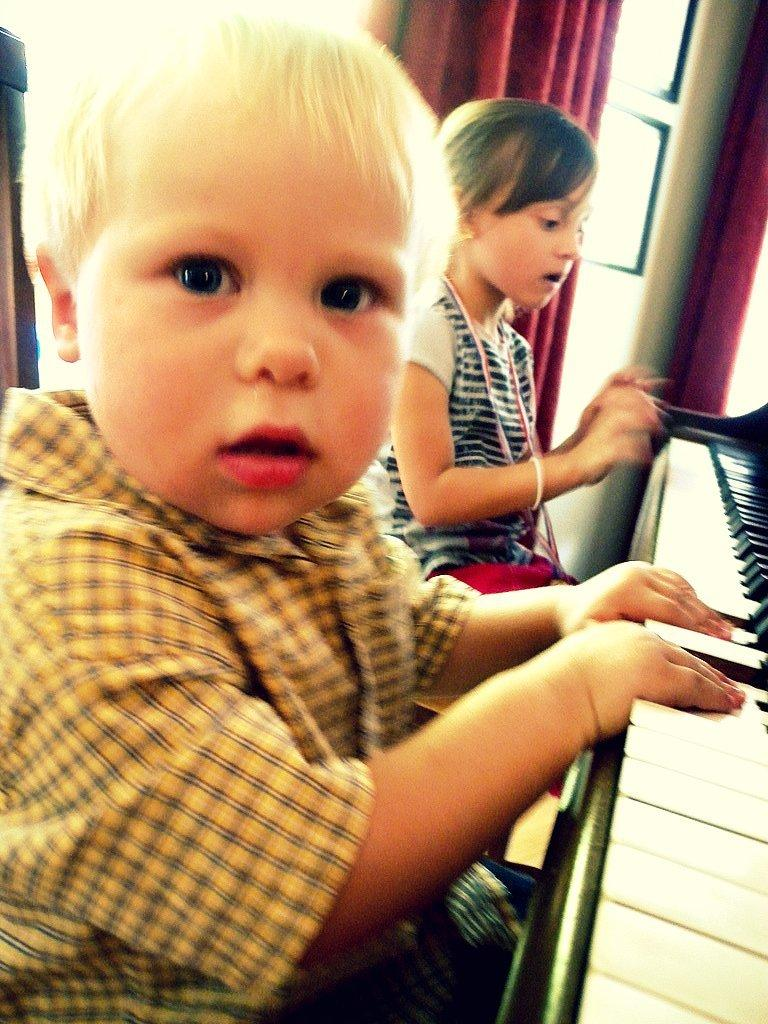How many kids are in the image? There are two kids in the image. What are the kids doing in the image? The kids are sitting, and one of them is playing a keyboard. Can you describe the keyboard? The keyboard has black and white keys. What can be seen in the background of the image? There is a door, curtains, and a wall visible in the background. What type of butter is being used to lubricate the yoke in the image? There is no butter or yoke present in the image; it features two kids sitting, with one playing a keyboard. Is there a ship visible in the image? No, there is no ship present in the image. 